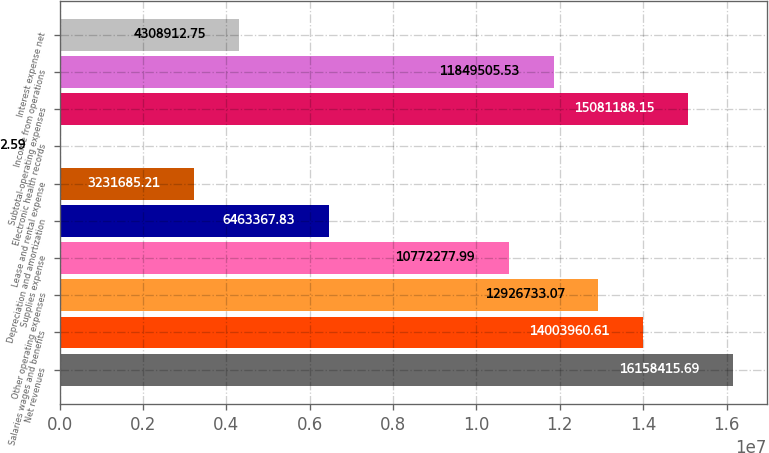Convert chart. <chart><loc_0><loc_0><loc_500><loc_500><bar_chart><fcel>Net revenues<fcel>Salaries wages and benefits<fcel>Other operating expenses<fcel>Supplies expense<fcel>Depreciation and amortization<fcel>Lease and rental expense<fcel>Electronic health records<fcel>Subtotal-operating expenses<fcel>Income from operations<fcel>Interest expense net<nl><fcel>1.61584e+07<fcel>1.4004e+07<fcel>1.29267e+07<fcel>1.07723e+07<fcel>6.46337e+06<fcel>3.23169e+06<fcel>2.59<fcel>1.50812e+07<fcel>1.18495e+07<fcel>4.30891e+06<nl></chart> 